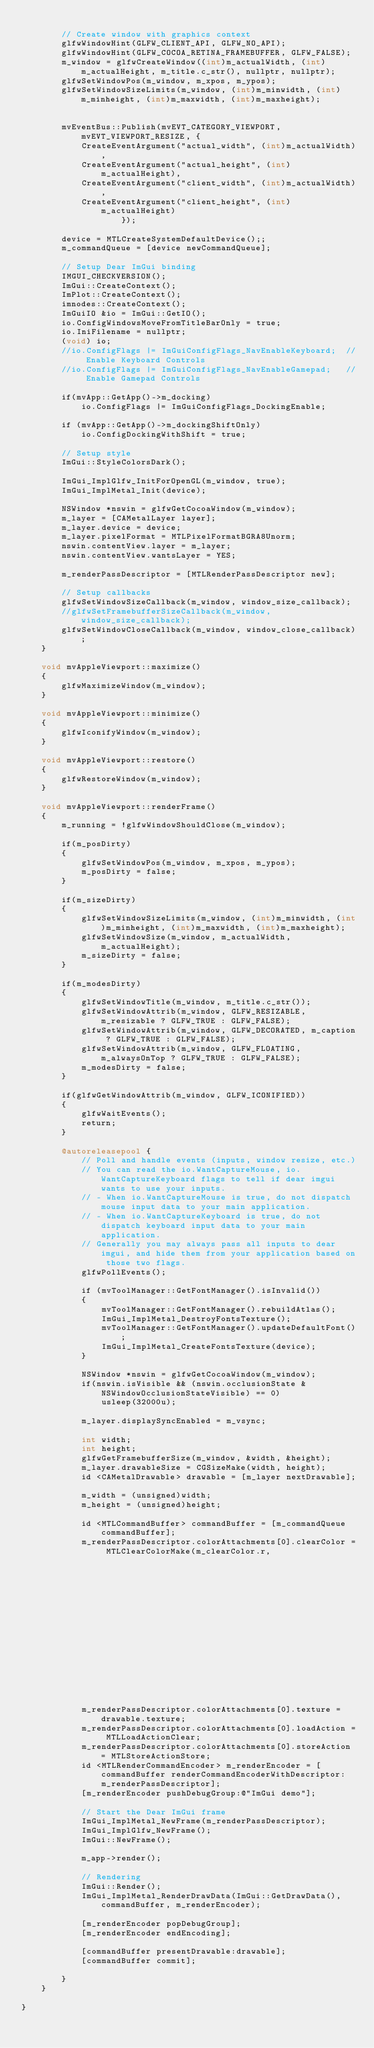<code> <loc_0><loc_0><loc_500><loc_500><_ObjectiveC_>
        // Create window with graphics context
        glfwWindowHint(GLFW_CLIENT_API, GLFW_NO_API);
        glfwWindowHint(GLFW_COCOA_RETINA_FRAMEBUFFER, GLFW_FALSE);
        m_window = glfwCreateWindow((int)m_actualWidth, (int)m_actualHeight, m_title.c_str(), nullptr, nullptr);
        glfwSetWindowPos(m_window, m_xpos, m_ypos);
        glfwSetWindowSizeLimits(m_window, (int)m_minwidth, (int)m_minheight, (int)m_maxwidth, (int)m_maxheight);


        mvEventBus::Publish(mvEVT_CATEGORY_VIEWPORT, mvEVT_VIEWPORT_RESIZE, {
            CreateEventArgument("actual_width", (int)m_actualWidth),
            CreateEventArgument("actual_height", (int)m_actualHeight),
            CreateEventArgument("client_width", (int)m_actualWidth),
            CreateEventArgument("client_height", (int)m_actualHeight)
                    });

        device = MTLCreateSystemDefaultDevice();;
        m_commandQueue = [device newCommandQueue];

        // Setup Dear ImGui binding
        IMGUI_CHECKVERSION();
        ImGui::CreateContext();
        ImPlot::CreateContext();
        imnodes::CreateContext();
        ImGuiIO &io = ImGui::GetIO();
        io.ConfigWindowsMoveFromTitleBarOnly = true;
        io.IniFilename = nullptr;
        (void) io;
        //io.ConfigFlags |= ImGuiConfigFlags_NavEnableKeyboard;  // Enable Keyboard Controls
        //io.ConfigFlags |= ImGuiConfigFlags_NavEnableGamepad;   // Enable Gamepad Controls

        if(mvApp::GetApp()->m_docking)
            io.ConfigFlags |= ImGuiConfigFlags_DockingEnable;

        if (mvApp::GetApp()->m_dockingShiftOnly)
            io.ConfigDockingWithShift = true;

        // Setup style
        ImGui::StyleColorsDark();

        ImGui_ImplGlfw_InitForOpenGL(m_window, true);
        ImGui_ImplMetal_Init(device);

        NSWindow *nswin = glfwGetCocoaWindow(m_window);
        m_layer = [CAMetalLayer layer];
        m_layer.device = device;
        m_layer.pixelFormat = MTLPixelFormatBGRA8Unorm;
        nswin.contentView.layer = m_layer;
        nswin.contentView.wantsLayer = YES;

        m_renderPassDescriptor = [MTLRenderPassDescriptor new];

        // Setup callbacks
        glfwSetWindowSizeCallback(m_window, window_size_callback);
        //glfwSetFramebufferSizeCallback(m_window, window_size_callback);
        glfwSetWindowCloseCallback(m_window, window_close_callback);
    }

    void mvAppleViewport::maximize()
	{
        glfwMaximizeWindow(m_window);
	}

	void mvAppleViewport::minimize()
	{
        glfwIconifyWindow(m_window);
	}

    void mvAppleViewport::restore()
    {
        glfwRestoreWindow(m_window);
    }

    void mvAppleViewport::renderFrame()
    {
        m_running = !glfwWindowShouldClose(m_window);

        if(m_posDirty)
        {
            glfwSetWindowPos(m_window, m_xpos, m_ypos);
            m_posDirty = false;
        }

        if(m_sizeDirty)
        {
            glfwSetWindowSizeLimits(m_window, (int)m_minwidth, (int)m_minheight, (int)m_maxwidth, (int)m_maxheight);
            glfwSetWindowSize(m_window, m_actualWidth, m_actualHeight);
            m_sizeDirty = false;
        }

        if(m_modesDirty)
        {
            glfwSetWindowTitle(m_window, m_title.c_str());
            glfwSetWindowAttrib(m_window, GLFW_RESIZABLE, m_resizable ? GLFW_TRUE : GLFW_FALSE);
            glfwSetWindowAttrib(m_window, GLFW_DECORATED, m_caption ? GLFW_TRUE : GLFW_FALSE);
            glfwSetWindowAttrib(m_window, GLFW_FLOATING, m_alwaysOnTop ? GLFW_TRUE : GLFW_FALSE);
            m_modesDirty = false;
        }

        if(glfwGetWindowAttrib(m_window, GLFW_ICONIFIED))
        {
            glfwWaitEvents();
            return;
        }

        @autoreleasepool {
            // Poll and handle events (inputs, window resize, etc.)
            // You can read the io.WantCaptureMouse, io.WantCaptureKeyboard flags to tell if dear imgui wants to use your inputs.
            // - When io.WantCaptureMouse is true, do not dispatch mouse input data to your main application.
            // - When io.WantCaptureKeyboard is true, do not dispatch keyboard input data to your main application.
            // Generally you may always pass all inputs to dear imgui, and hide them from your application based on those two flags.
            glfwPollEvents();

            if (mvToolManager::GetFontManager().isInvalid())
            {
                mvToolManager::GetFontManager().rebuildAtlas();
                ImGui_ImplMetal_DestroyFontsTexture();
                mvToolManager::GetFontManager().updateDefaultFont();
                ImGui_ImplMetal_CreateFontsTexture(device);
            }

            NSWindow *nswin = glfwGetCocoaWindow(m_window);
            if(nswin.isVisible && (nswin.occlusionState & NSWindowOcclusionStateVisible) == 0)
                usleep(32000u);

            m_layer.displaySyncEnabled = m_vsync;

            int width;
            int height;
            glfwGetFramebufferSize(m_window, &width, &height);
            m_layer.drawableSize = CGSizeMake(width, height);
            id <CAMetalDrawable> drawable = [m_layer nextDrawable];

            m_width = (unsigned)width;
            m_height = (unsigned)height;

            id <MTLCommandBuffer> commandBuffer = [m_commandQueue commandBuffer];
            m_renderPassDescriptor.colorAttachments[0].clearColor = MTLClearColorMake(m_clearColor.r,
                                                                                      m_clearColor.g,
                                                                                      m_clearColor.b,
                                                                                      m_clearColor.a);
            m_renderPassDescriptor.colorAttachments[0].texture = drawable.texture;
            m_renderPassDescriptor.colorAttachments[0].loadAction = MTLLoadActionClear;
            m_renderPassDescriptor.colorAttachments[0].storeAction = MTLStoreActionStore;
            id <MTLRenderCommandEncoder> m_renderEncoder = [commandBuffer renderCommandEncoderWithDescriptor:m_renderPassDescriptor];
            [m_renderEncoder pushDebugGroup:@"ImGui demo"];

            // Start the Dear ImGui frame
            ImGui_ImplMetal_NewFrame(m_renderPassDescriptor);
            ImGui_ImplGlfw_NewFrame();
            ImGui::NewFrame();

            m_app->render();

            // Rendering
            ImGui::Render();
            ImGui_ImplMetal_RenderDrawData(ImGui::GetDrawData(), commandBuffer, m_renderEncoder);

            [m_renderEncoder popDebugGroup];
            [m_renderEncoder endEncoding];

            [commandBuffer presentDrawable:drawable];
            [commandBuffer commit];

        }
	}

}
</code> 